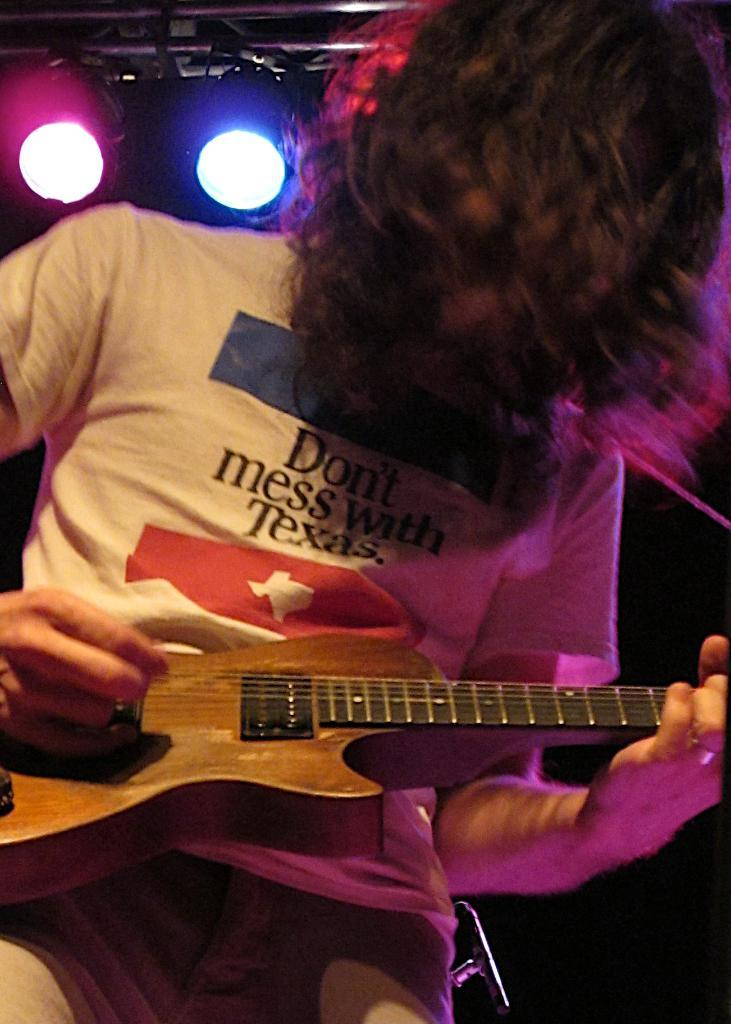What is the main subject of the image? There is a person in the image. Can you describe the person's appearance? The person has short hair. What is the person doing in the image? The person is playing a guitar. What can be seen at the top of the image? There are lights visible at the top of the image. How would you describe the background of the image? The background of the image is dark. What type of current is flowing through the sponge in the image? There is no sponge or current present in the image. 